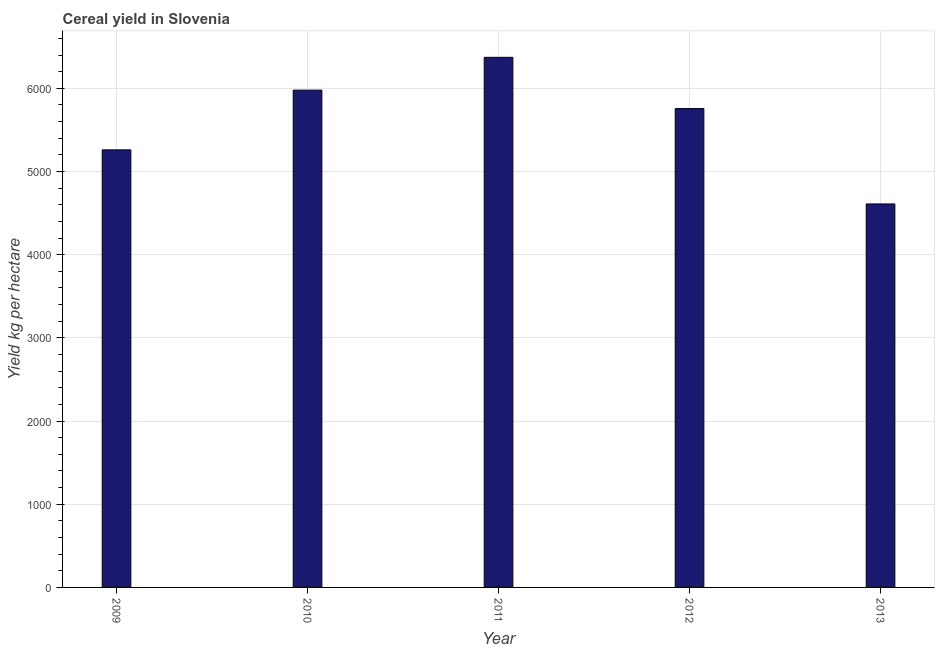Does the graph contain any zero values?
Provide a succinct answer. No. What is the title of the graph?
Ensure brevity in your answer.  Cereal yield in Slovenia. What is the label or title of the Y-axis?
Provide a succinct answer. Yield kg per hectare. What is the cereal yield in 2009?
Your answer should be very brief. 5259.7. Across all years, what is the maximum cereal yield?
Keep it short and to the point. 6372.08. Across all years, what is the minimum cereal yield?
Make the answer very short. 4609.73. What is the sum of the cereal yield?
Offer a terse response. 2.80e+04. What is the difference between the cereal yield in 2009 and 2011?
Offer a terse response. -1112.38. What is the average cereal yield per year?
Your response must be concise. 5594.98. What is the median cereal yield?
Keep it short and to the point. 5755.87. In how many years, is the cereal yield greater than 5200 kg per hectare?
Keep it short and to the point. 4. Do a majority of the years between 2011 and 2013 (inclusive) have cereal yield greater than 4800 kg per hectare?
Provide a succinct answer. Yes. What is the ratio of the cereal yield in 2011 to that in 2012?
Keep it short and to the point. 1.11. Is the cereal yield in 2010 less than that in 2011?
Give a very brief answer. Yes. Is the difference between the cereal yield in 2012 and 2013 greater than the difference between any two years?
Give a very brief answer. No. What is the difference between the highest and the second highest cereal yield?
Your answer should be compact. 394.59. What is the difference between the highest and the lowest cereal yield?
Keep it short and to the point. 1762.36. In how many years, is the cereal yield greater than the average cereal yield taken over all years?
Offer a terse response. 3. Are all the bars in the graph horizontal?
Provide a succinct answer. No. What is the difference between two consecutive major ticks on the Y-axis?
Make the answer very short. 1000. What is the Yield kg per hectare of 2009?
Keep it short and to the point. 5259.7. What is the Yield kg per hectare in 2010?
Your answer should be compact. 5977.49. What is the Yield kg per hectare in 2011?
Provide a succinct answer. 6372.08. What is the Yield kg per hectare of 2012?
Offer a terse response. 5755.87. What is the Yield kg per hectare of 2013?
Give a very brief answer. 4609.73. What is the difference between the Yield kg per hectare in 2009 and 2010?
Your response must be concise. -717.79. What is the difference between the Yield kg per hectare in 2009 and 2011?
Make the answer very short. -1112.38. What is the difference between the Yield kg per hectare in 2009 and 2012?
Your response must be concise. -496.16. What is the difference between the Yield kg per hectare in 2009 and 2013?
Provide a succinct answer. 649.98. What is the difference between the Yield kg per hectare in 2010 and 2011?
Your answer should be compact. -394.59. What is the difference between the Yield kg per hectare in 2010 and 2012?
Offer a terse response. 221.63. What is the difference between the Yield kg per hectare in 2010 and 2013?
Keep it short and to the point. 1367.77. What is the difference between the Yield kg per hectare in 2011 and 2012?
Ensure brevity in your answer.  616.22. What is the difference between the Yield kg per hectare in 2011 and 2013?
Keep it short and to the point. 1762.36. What is the difference between the Yield kg per hectare in 2012 and 2013?
Give a very brief answer. 1146.14. What is the ratio of the Yield kg per hectare in 2009 to that in 2011?
Provide a succinct answer. 0.82. What is the ratio of the Yield kg per hectare in 2009 to that in 2012?
Your answer should be compact. 0.91. What is the ratio of the Yield kg per hectare in 2009 to that in 2013?
Make the answer very short. 1.14. What is the ratio of the Yield kg per hectare in 2010 to that in 2011?
Provide a succinct answer. 0.94. What is the ratio of the Yield kg per hectare in 2010 to that in 2012?
Your response must be concise. 1.04. What is the ratio of the Yield kg per hectare in 2010 to that in 2013?
Offer a very short reply. 1.3. What is the ratio of the Yield kg per hectare in 2011 to that in 2012?
Your response must be concise. 1.11. What is the ratio of the Yield kg per hectare in 2011 to that in 2013?
Make the answer very short. 1.38. What is the ratio of the Yield kg per hectare in 2012 to that in 2013?
Your answer should be very brief. 1.25. 